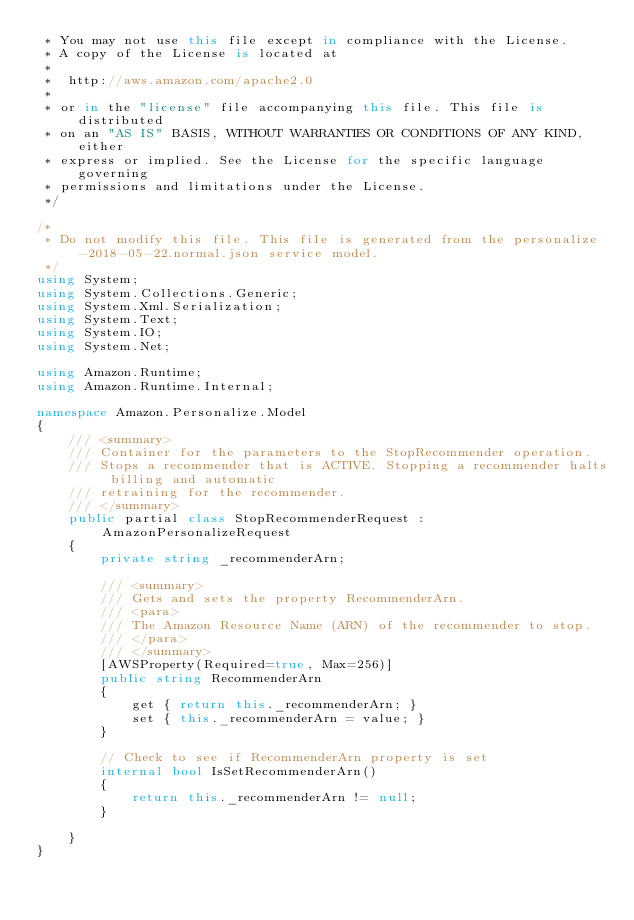<code> <loc_0><loc_0><loc_500><loc_500><_C#_> * You may not use this file except in compliance with the License.
 * A copy of the License is located at
 * 
 *  http://aws.amazon.com/apache2.0
 * 
 * or in the "license" file accompanying this file. This file is distributed
 * on an "AS IS" BASIS, WITHOUT WARRANTIES OR CONDITIONS OF ANY KIND, either
 * express or implied. See the License for the specific language governing
 * permissions and limitations under the License.
 */

/*
 * Do not modify this file. This file is generated from the personalize-2018-05-22.normal.json service model.
 */
using System;
using System.Collections.Generic;
using System.Xml.Serialization;
using System.Text;
using System.IO;
using System.Net;

using Amazon.Runtime;
using Amazon.Runtime.Internal;

namespace Amazon.Personalize.Model
{
    /// <summary>
    /// Container for the parameters to the StopRecommender operation.
    /// Stops a recommender that is ACTIVE. Stopping a recommender halts billing and automatic
    /// retraining for the recommender.
    /// </summary>
    public partial class StopRecommenderRequest : AmazonPersonalizeRequest
    {
        private string _recommenderArn;

        /// <summary>
        /// Gets and sets the property RecommenderArn. 
        /// <para>
        /// The Amazon Resource Name (ARN) of the recommender to stop.
        /// </para>
        /// </summary>
        [AWSProperty(Required=true, Max=256)]
        public string RecommenderArn
        {
            get { return this._recommenderArn; }
            set { this._recommenderArn = value; }
        }

        // Check to see if RecommenderArn property is set
        internal bool IsSetRecommenderArn()
        {
            return this._recommenderArn != null;
        }

    }
}</code> 